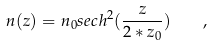Convert formula to latex. <formula><loc_0><loc_0><loc_500><loc_500>n ( z ) = n _ { 0 } s e c h ^ { 2 } ( \frac { z } { 2 * z _ { 0 } } ) \quad ,</formula> 